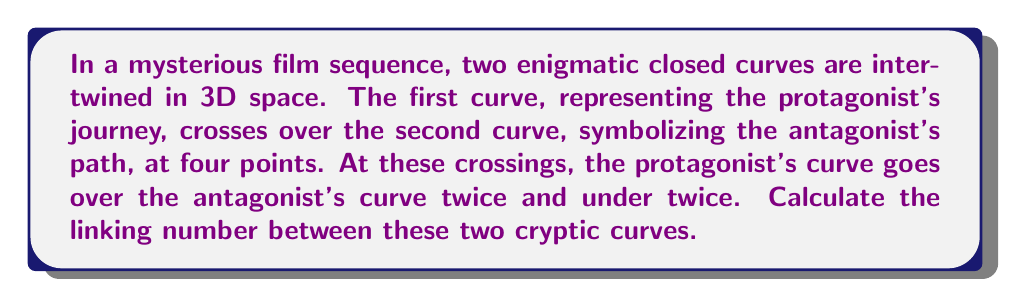Could you help me with this problem? To calculate the linking number between two closed curves in 3D space, we follow these steps:

1) Assign an orientation to each curve. In this case, we can arbitrarily choose a direction for each curve.

2) At each crossing point, determine the sign of the crossing:
   - If the upper strand's orientation aligns with the right-hand rule relative to the lower strand's orientation, assign +1.
   - If it's opposite to the right-hand rule, assign -1.

3) Sum up all these signs and divide by 2 to get the linking number.

In our case:
- There are 4 crossing points in total.
- The protagonist's curve goes over twice and under twice.

Let's assume the over crossings contribute +1 each, and the under crossings contribute -1 each:

$$ \text{Sum of crossings} = (+1) + (+1) + (-1) + (-1) = 0 $$

4) Calculate the linking number:

$$ \text{Linking Number} = \frac{\text{Sum of crossings}}{2} = \frac{0}{2} = 0 $$

The linking number being 0 suggests that despite their apparent entanglement, the curves can be separated without cutting either one, adding to the enigmatic nature of the film sequence.
Answer: $0$ 